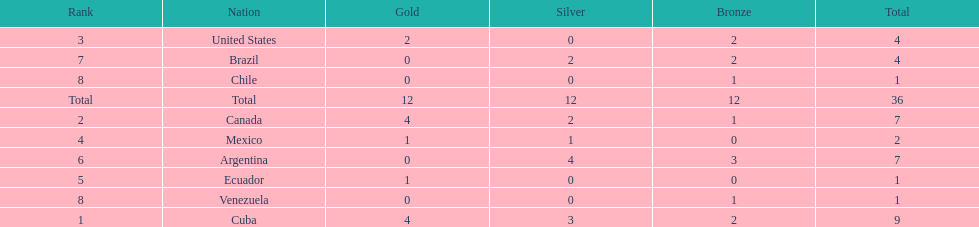Who had more silver medals, cuba or brazil? Cuba. 